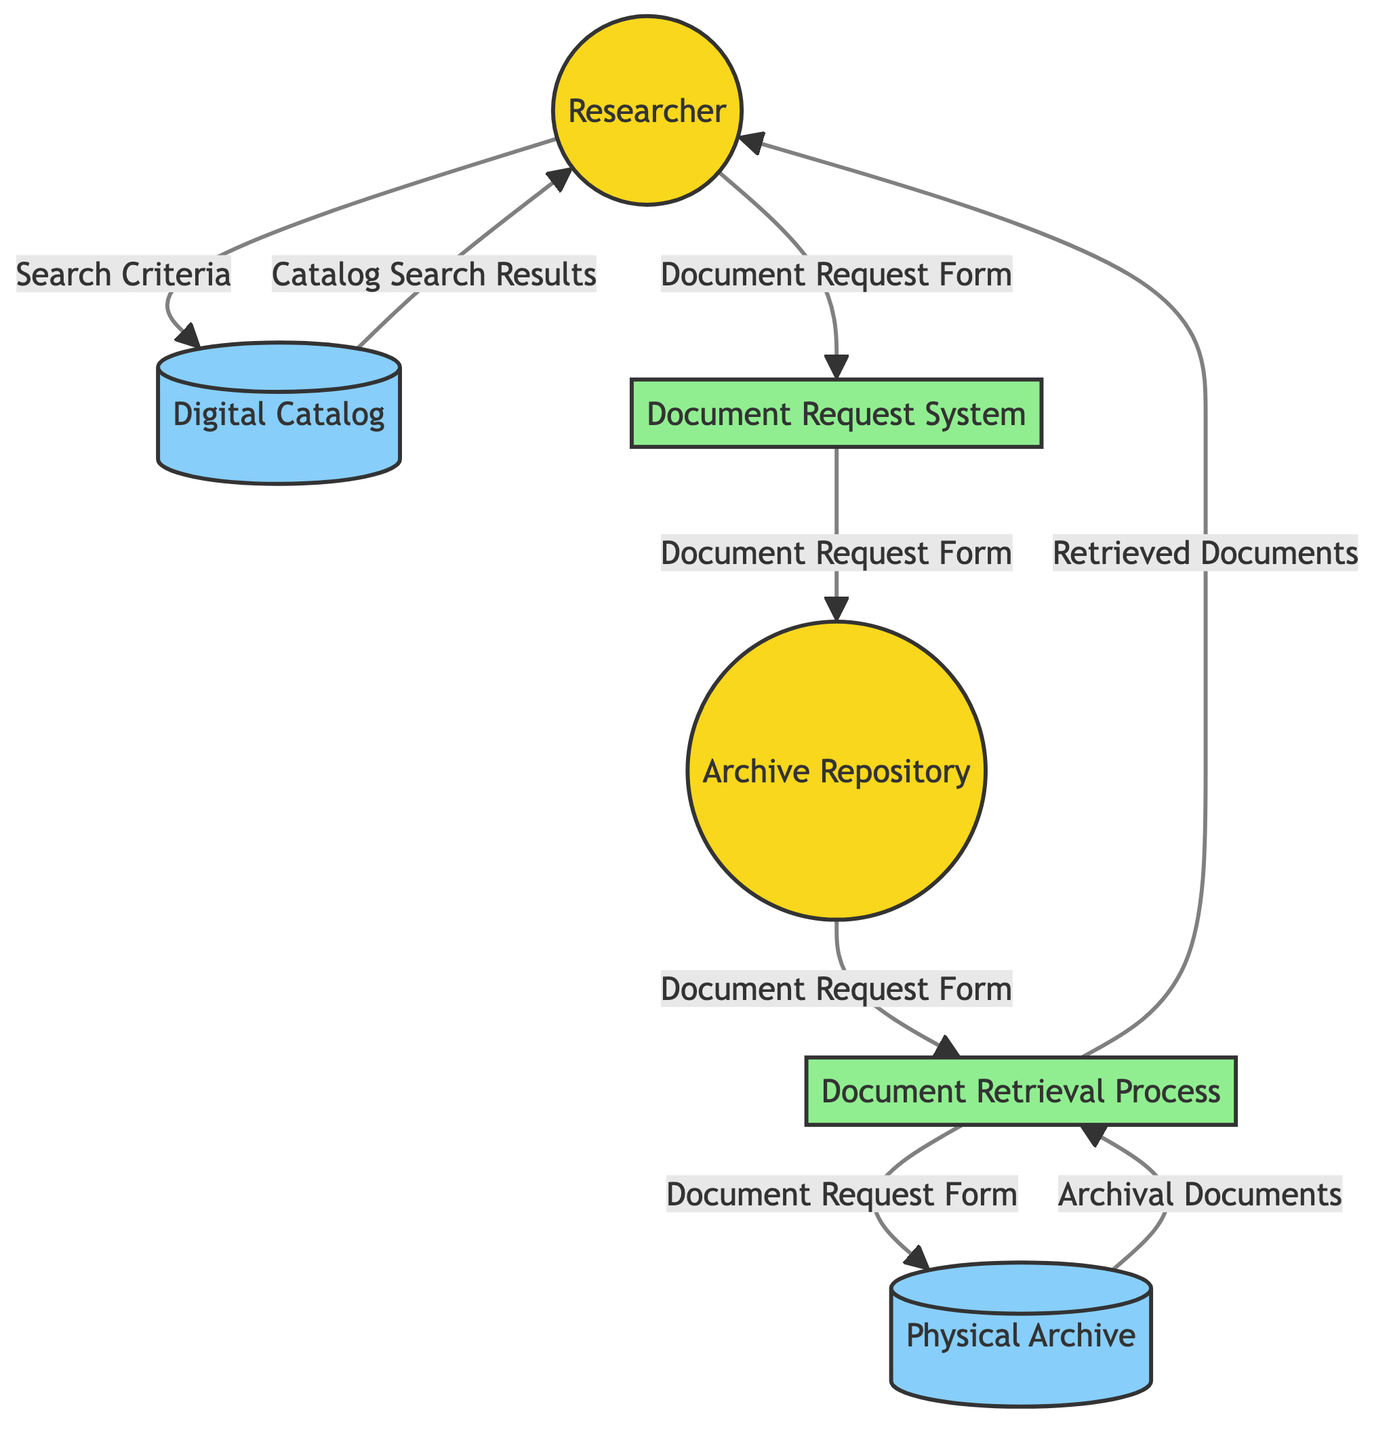What are the external entities in this diagram? The diagram includes two external entities: the Researcher and the Archive Repository. These are represented in the diagram with a distinct style indicating their type.
Answer: Researcher, Archive Repository How many data stores are present in the diagram? There are two data stores in the diagram: the Digital Catalog and the Physical Archive. This can be determined by counting the nodes labeled as data stores.
Answer: 2 What is the output data flow from the Document Retrieval Process to the Researcher? The output data flow from the Document Retrieval Process to the Researcher is labeled as Retrieved Documents. This is directly indicated by the arrow and label connecting the two.
Answer: Retrieved Documents What initiates the interaction between the Researcher and the Digital Catalog? The interaction is initiated by the Search Criteria provided by the Researcher, which is shown as the data flow from the Researcher to the Digital Catalog.
Answer: Search Criteria What process receives the Document Request Form from the Document Request System? The Archive Repository receives the Document Request Form from the Document Request System. The diagram indicates this flow with an arrow showing the direction of data transfer.
Answer: Archive Repository Which process is responsible for retrieving documents from the Physical Archive? The Document Retrieval Process is responsible for retrieving documents from the Physical Archive, as indicated by the direct flow of data from the Physical Archive to this process.
Answer: Document Retrieval Process What type of diagram is represented here? The diagram is a Data Flow Diagram, which visualizes the flow of information between various entities, data stores, and processes in the archival research process.
Answer: Data Flow Diagram How many processes are depicted in the diagram? There are two processes depicted: the Document Request System and the Document Retrieval Process. By identifying the nodes classified as processes, this count can be confirmed.
Answer: 2 What is the flow of Archival Documents after retrieval? After retrieval, the flow of Archival Documents goes from the Physical Archive to the Document Retrieval Process, as indicated by the arrow connecting them.
Answer: Document Retrieval Process 